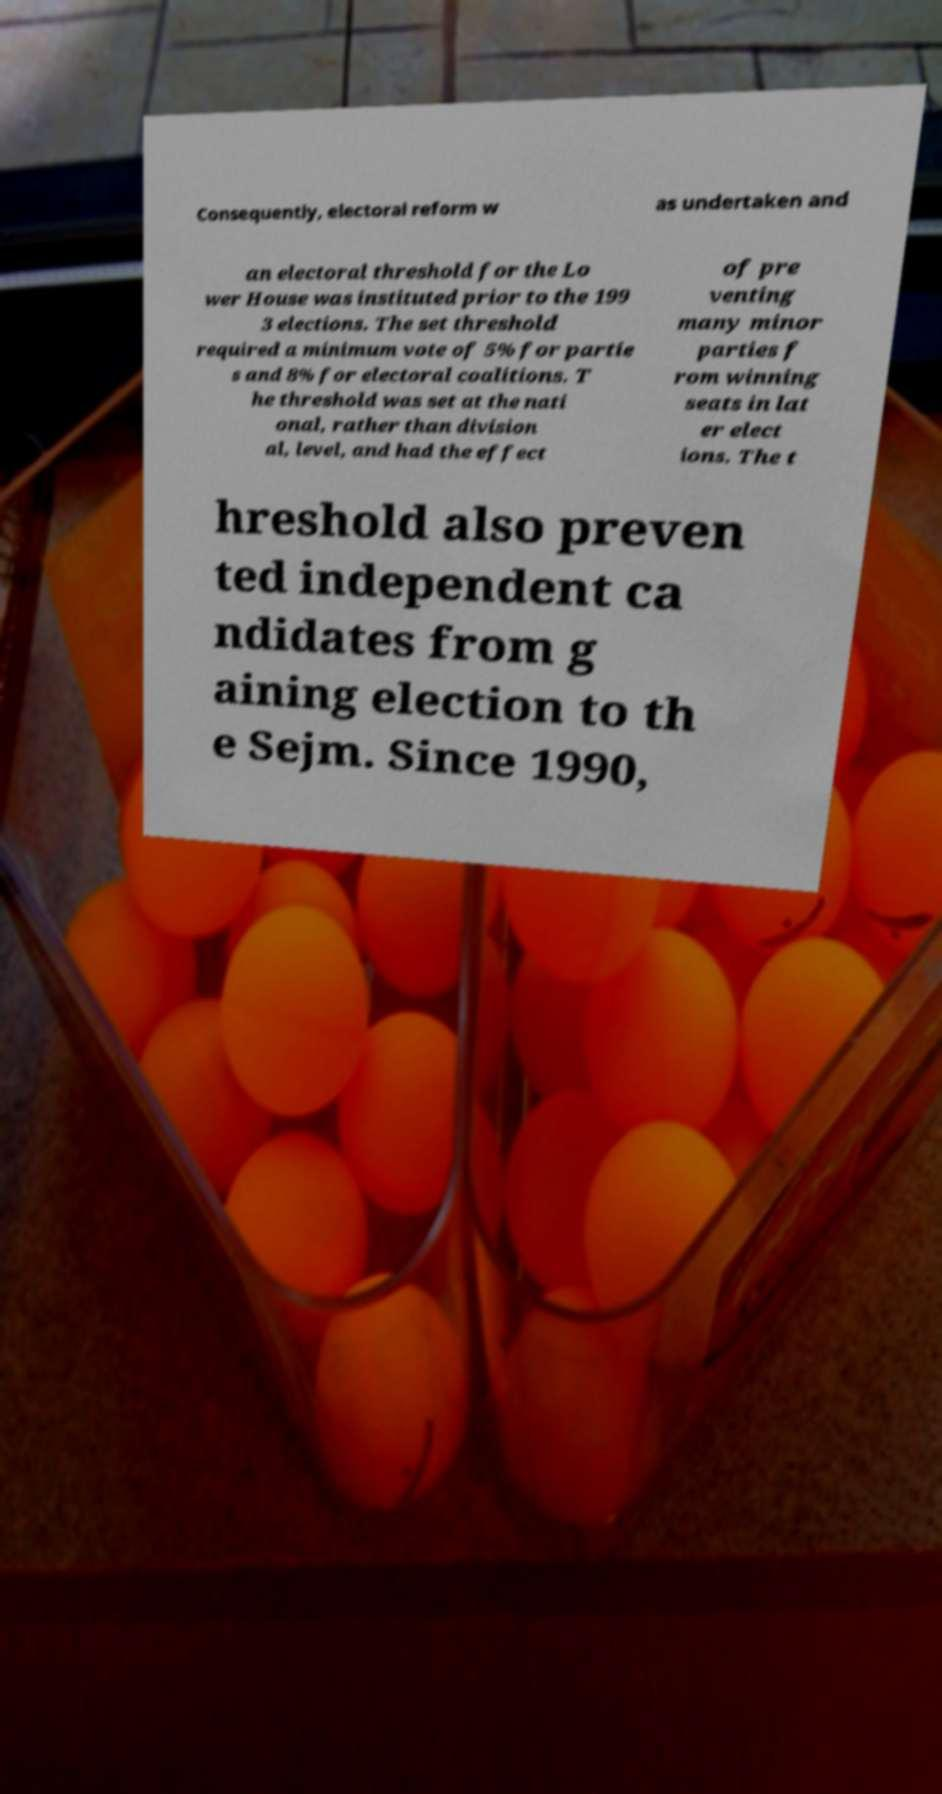I need the written content from this picture converted into text. Can you do that? Consequently, electoral reform w as undertaken and an electoral threshold for the Lo wer House was instituted prior to the 199 3 elections. The set threshold required a minimum vote of 5% for partie s and 8% for electoral coalitions. T he threshold was set at the nati onal, rather than division al, level, and had the effect of pre venting many minor parties f rom winning seats in lat er elect ions. The t hreshold also preven ted independent ca ndidates from g aining election to th e Sejm. Since 1990, 